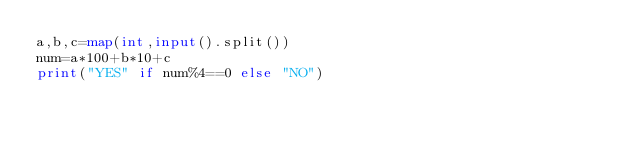Convert code to text. <code><loc_0><loc_0><loc_500><loc_500><_Python_>a,b,c=map(int,input().split())
num=a*100+b*10+c
print("YES" if num%4==0 else "NO")</code> 